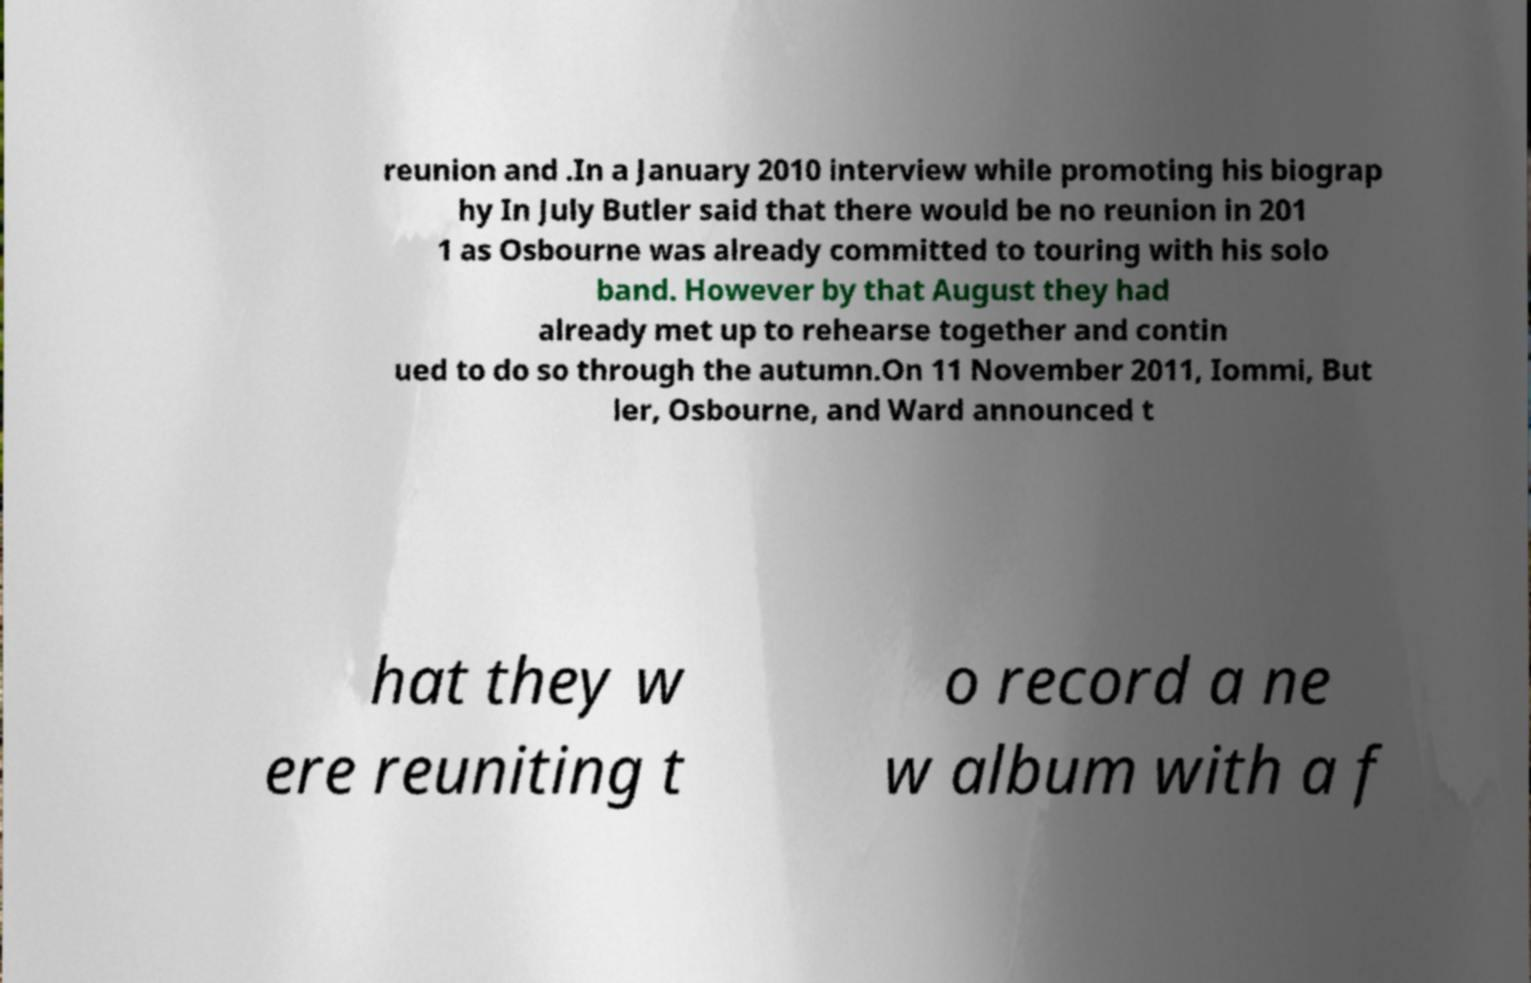Could you extract and type out the text from this image? reunion and .In a January 2010 interview while promoting his biograp hy In July Butler said that there would be no reunion in 201 1 as Osbourne was already committed to touring with his solo band. However by that August they had already met up to rehearse together and contin ued to do so through the autumn.On 11 November 2011, Iommi, But ler, Osbourne, and Ward announced t hat they w ere reuniting t o record a ne w album with a f 